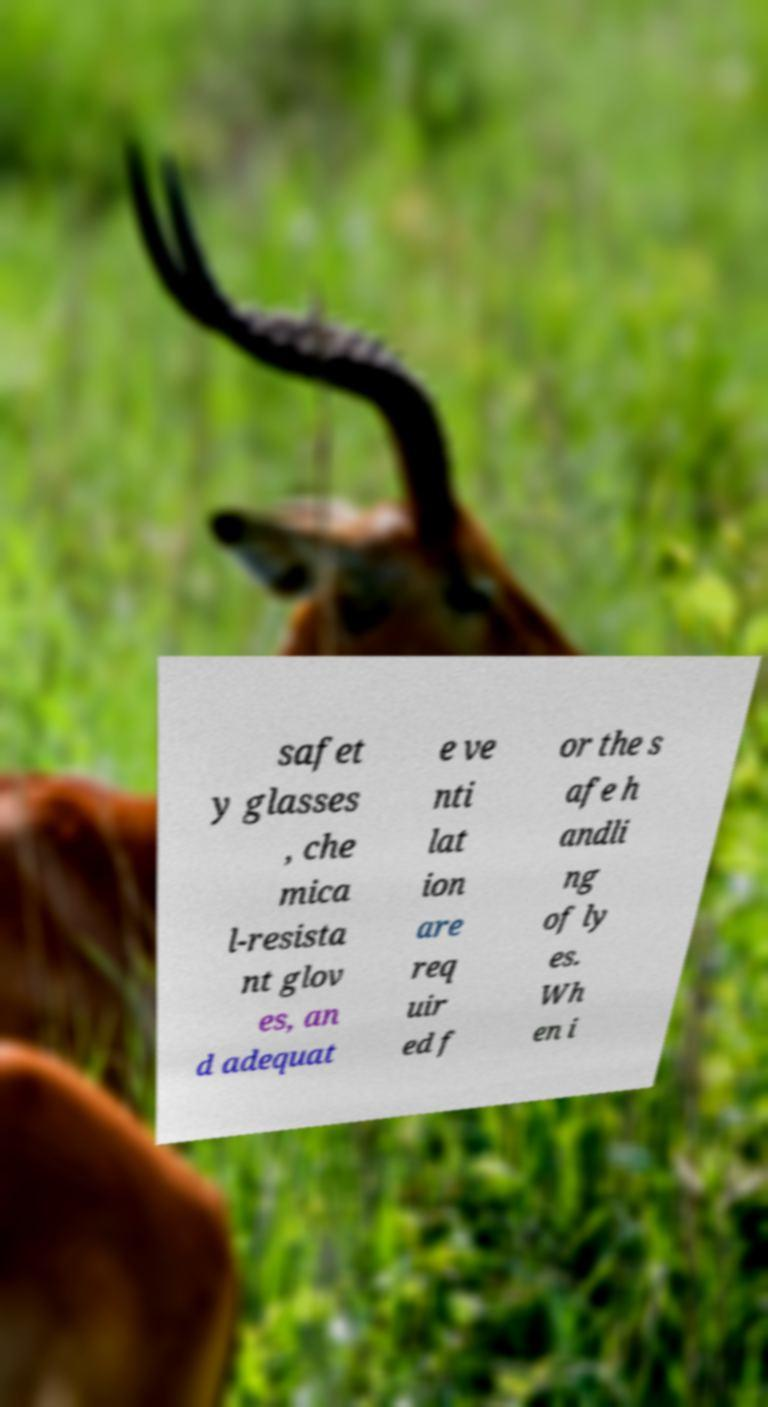Can you accurately transcribe the text from the provided image for me? safet y glasses , che mica l-resista nt glov es, an d adequat e ve nti lat ion are req uir ed f or the s afe h andli ng of ly es. Wh en i 